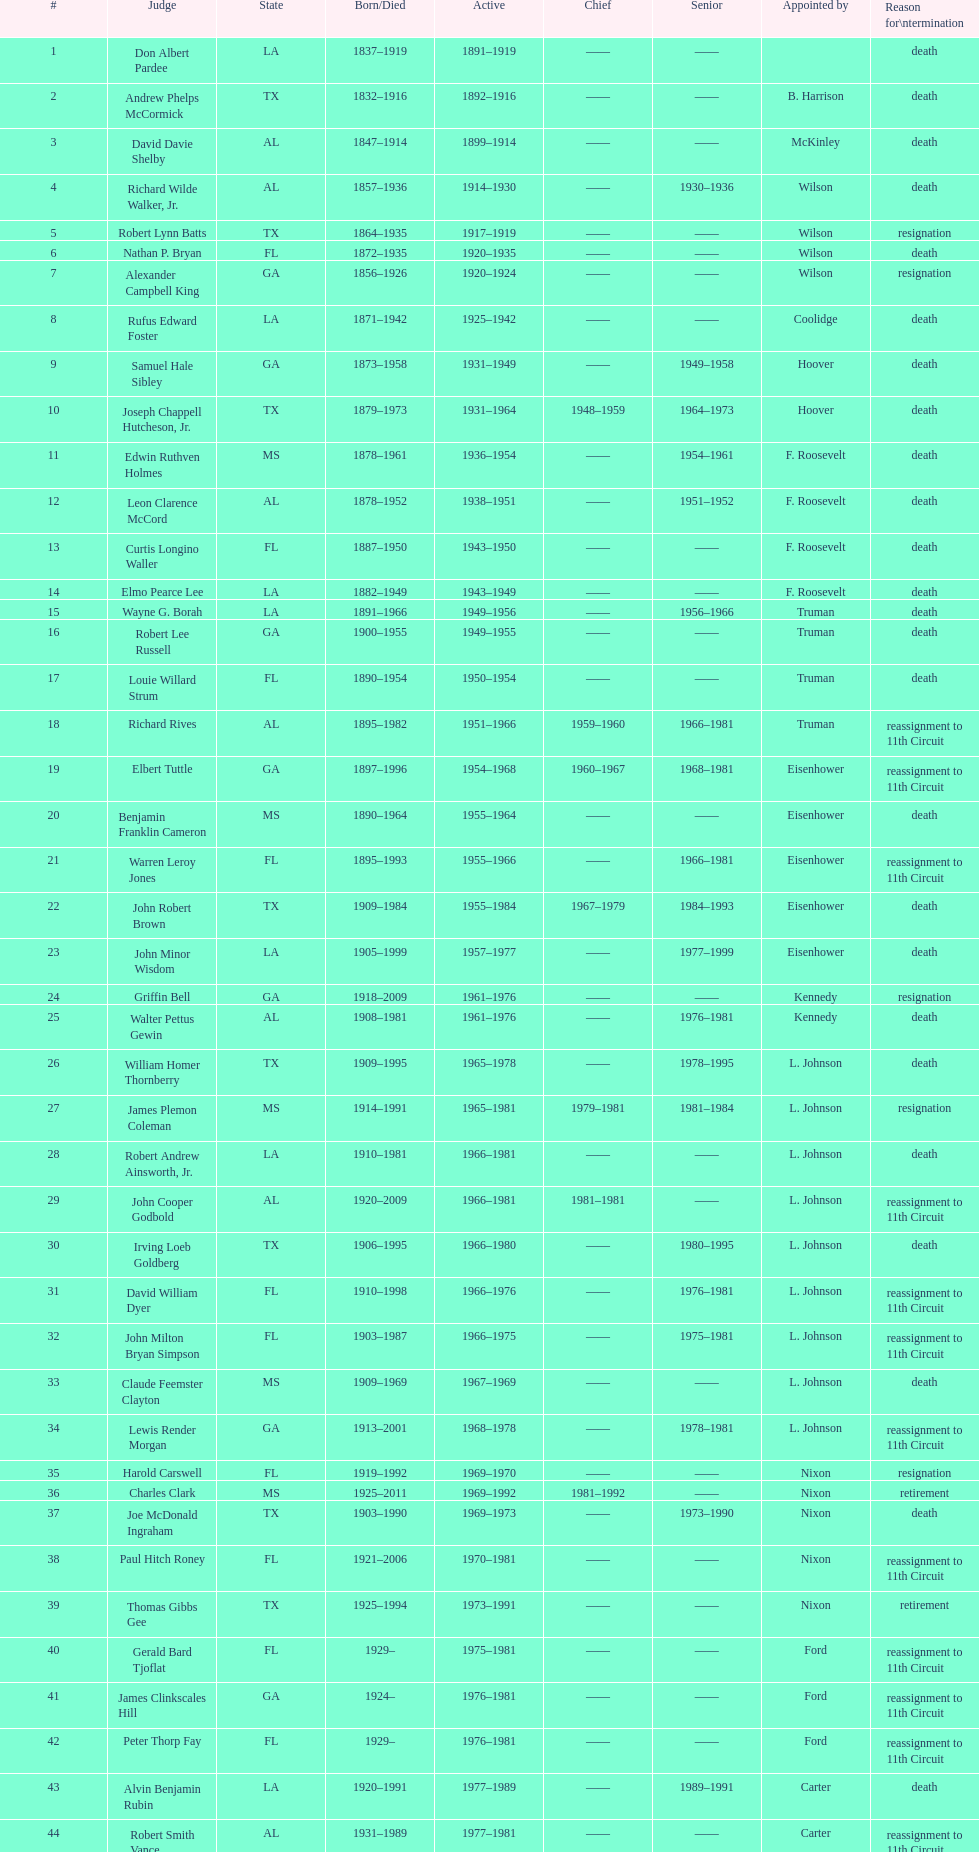Who was the first judge appointed from georgia? Alexander Campbell King. 